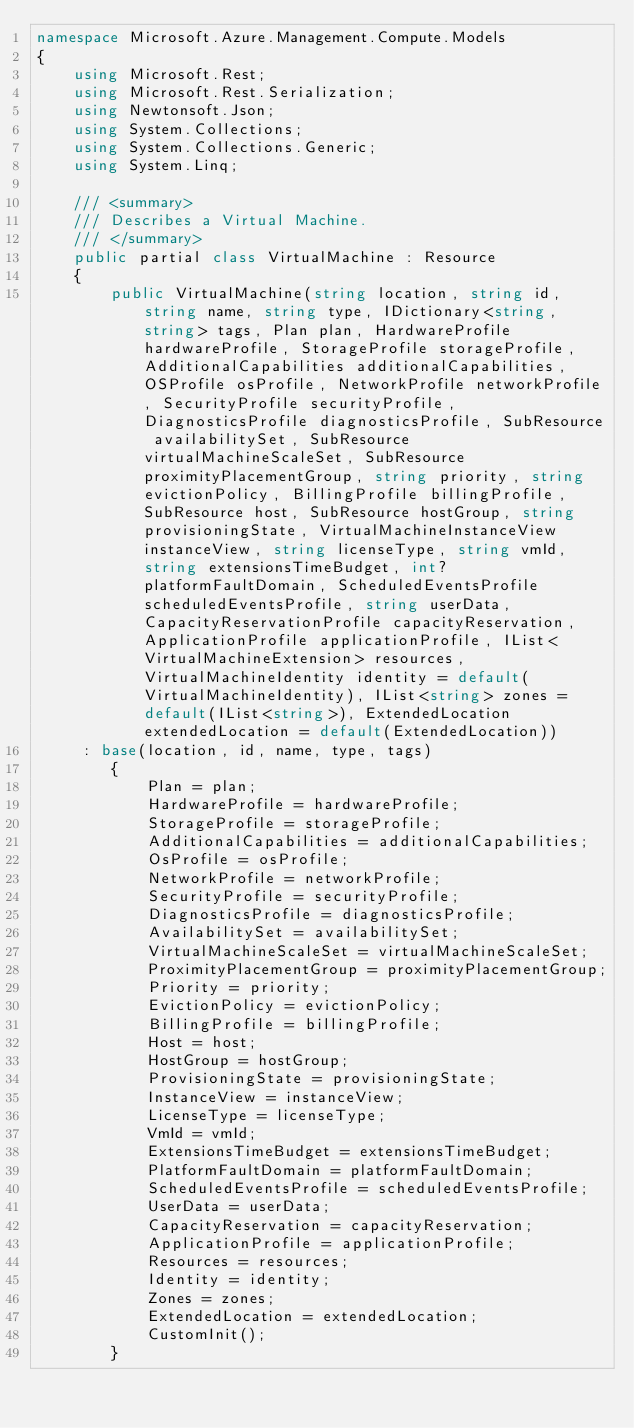Convert code to text. <code><loc_0><loc_0><loc_500><loc_500><_C#_>namespace Microsoft.Azure.Management.Compute.Models
{
    using Microsoft.Rest;
    using Microsoft.Rest.Serialization;
    using Newtonsoft.Json;
    using System.Collections;
    using System.Collections.Generic;
    using System.Linq;

    /// <summary>
    /// Describes a Virtual Machine.
    /// </summary>
    public partial class VirtualMachine : Resource
    {
        public VirtualMachine(string location, string id, string name, string type, IDictionary<string, string> tags, Plan plan, HardwareProfile hardwareProfile, StorageProfile storageProfile, AdditionalCapabilities additionalCapabilities, OSProfile osProfile, NetworkProfile networkProfile, SecurityProfile securityProfile, DiagnosticsProfile diagnosticsProfile, SubResource availabilitySet, SubResource virtualMachineScaleSet, SubResource proximityPlacementGroup, string priority, string evictionPolicy, BillingProfile billingProfile, SubResource host, SubResource hostGroup, string provisioningState, VirtualMachineInstanceView instanceView, string licenseType, string vmId, string extensionsTimeBudget, int? platformFaultDomain, ScheduledEventsProfile scheduledEventsProfile, string userData, CapacityReservationProfile capacityReservation, ApplicationProfile applicationProfile, IList<VirtualMachineExtension> resources, VirtualMachineIdentity identity = default(VirtualMachineIdentity), IList<string> zones = default(IList<string>), ExtendedLocation extendedLocation = default(ExtendedLocation))
     : base(location, id, name, type, tags)
        {
            Plan = plan;
            HardwareProfile = hardwareProfile;
            StorageProfile = storageProfile;
            AdditionalCapabilities = additionalCapabilities;
            OsProfile = osProfile;
            NetworkProfile = networkProfile;
            SecurityProfile = securityProfile;
            DiagnosticsProfile = diagnosticsProfile;
            AvailabilitySet = availabilitySet;
            VirtualMachineScaleSet = virtualMachineScaleSet;
            ProximityPlacementGroup = proximityPlacementGroup;
            Priority = priority;
            EvictionPolicy = evictionPolicy;
            BillingProfile = billingProfile;
            Host = host;
            HostGroup = hostGroup;
            ProvisioningState = provisioningState;
            InstanceView = instanceView;
            LicenseType = licenseType;
            VmId = vmId;
            ExtensionsTimeBudget = extensionsTimeBudget;
            PlatformFaultDomain = platformFaultDomain;
            ScheduledEventsProfile = scheduledEventsProfile;
            UserData = userData;
            CapacityReservation = capacityReservation;
            ApplicationProfile = applicationProfile;
            Resources = resources;
            Identity = identity;
            Zones = zones;
            ExtendedLocation = extendedLocation;
            CustomInit();
        }
</code> 